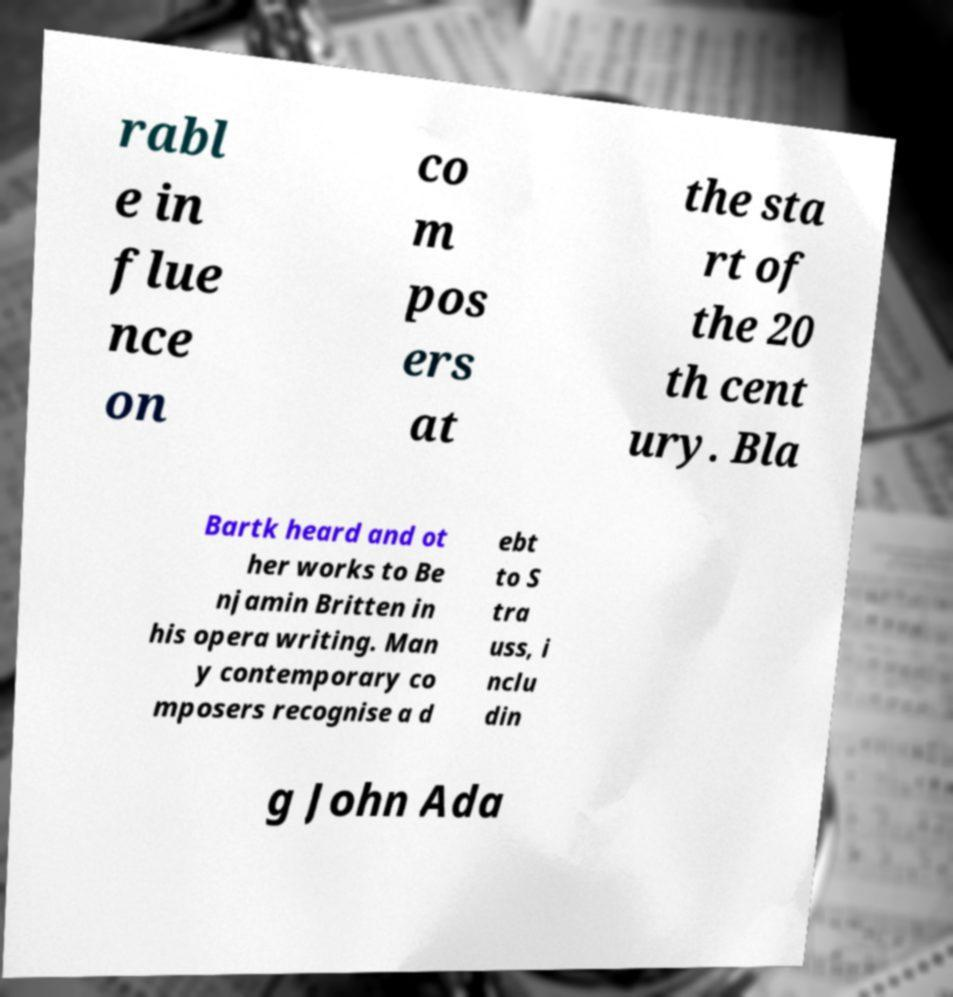Can you accurately transcribe the text from the provided image for me? rabl e in flue nce on co m pos ers at the sta rt of the 20 th cent ury. Bla Bartk heard and ot her works to Be njamin Britten in his opera writing. Man y contemporary co mposers recognise a d ebt to S tra uss, i nclu din g John Ada 